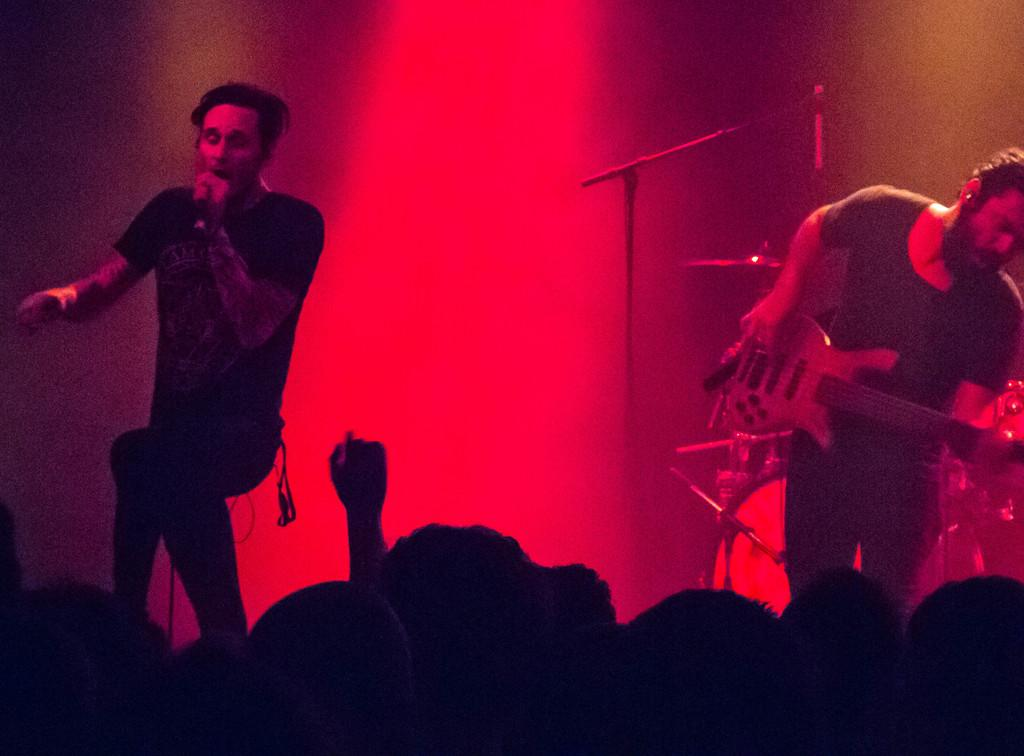What are the two people on stage doing? One person is playing the guitar, and the other person is singing. What type of event might be taking place based on the facts? It could be a musical performance or concert, as there are people performing on stage and others watching. How many people are performing on stage? There are two people performing on stage. What is the mind of the guitar thinking during the performance? The facts provided do not mention anything about the mind of the guitar, as it is an inanimate object. Is this a birthday celebration for one of the performers? There is no information in the facts provided to suggest that this is a birthday celebration. 